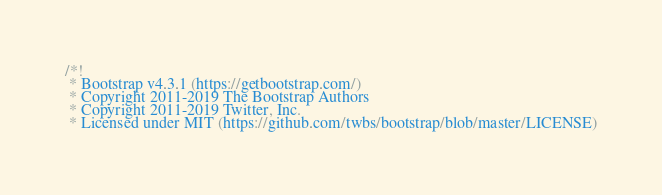<code> <loc_0><loc_0><loc_500><loc_500><_CSS_>/*!
 * Bootstrap v4.3.1 (https://getbootstrap.com/)
 * Copyright 2011-2019 The Bootstrap Authors
 * Copyright 2011-2019 Twitter, Inc.
 * Licensed under MIT (https://github.com/twbs/bootstrap/blob/master/LICENSE)</code> 